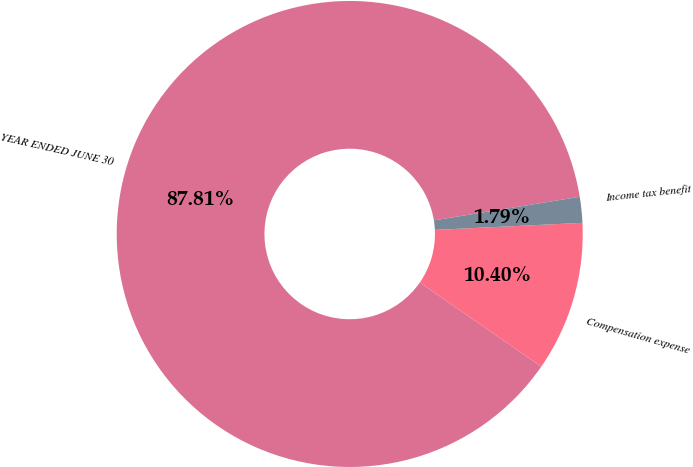<chart> <loc_0><loc_0><loc_500><loc_500><pie_chart><fcel>YEAR ENDED JUNE 30<fcel>Compensation expense<fcel>Income tax benefit<nl><fcel>87.81%<fcel>10.4%<fcel>1.79%<nl></chart> 